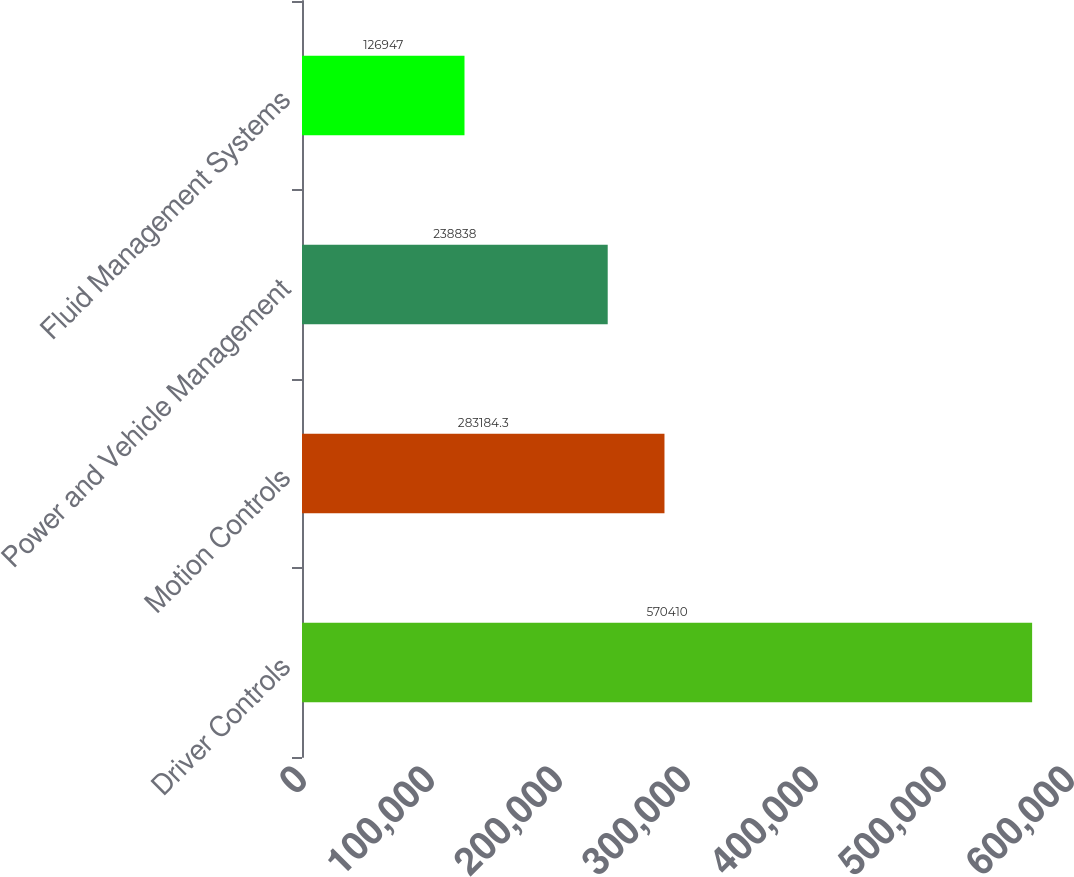Convert chart to OTSL. <chart><loc_0><loc_0><loc_500><loc_500><bar_chart><fcel>Driver Controls<fcel>Motion Controls<fcel>Power and Vehicle Management<fcel>Fluid Management Systems<nl><fcel>570410<fcel>283184<fcel>238838<fcel>126947<nl></chart> 